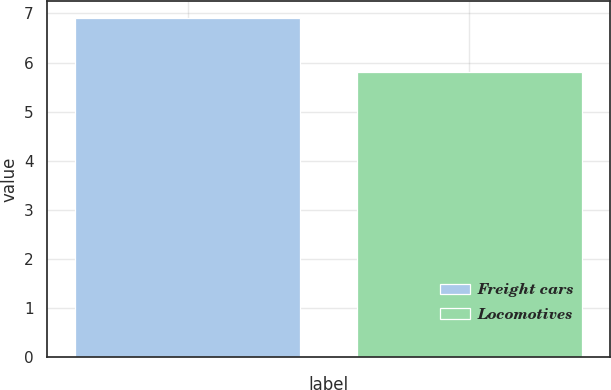Convert chart to OTSL. <chart><loc_0><loc_0><loc_500><loc_500><bar_chart><fcel>Freight cars<fcel>Locomotives<nl><fcel>6.9<fcel>5.8<nl></chart> 